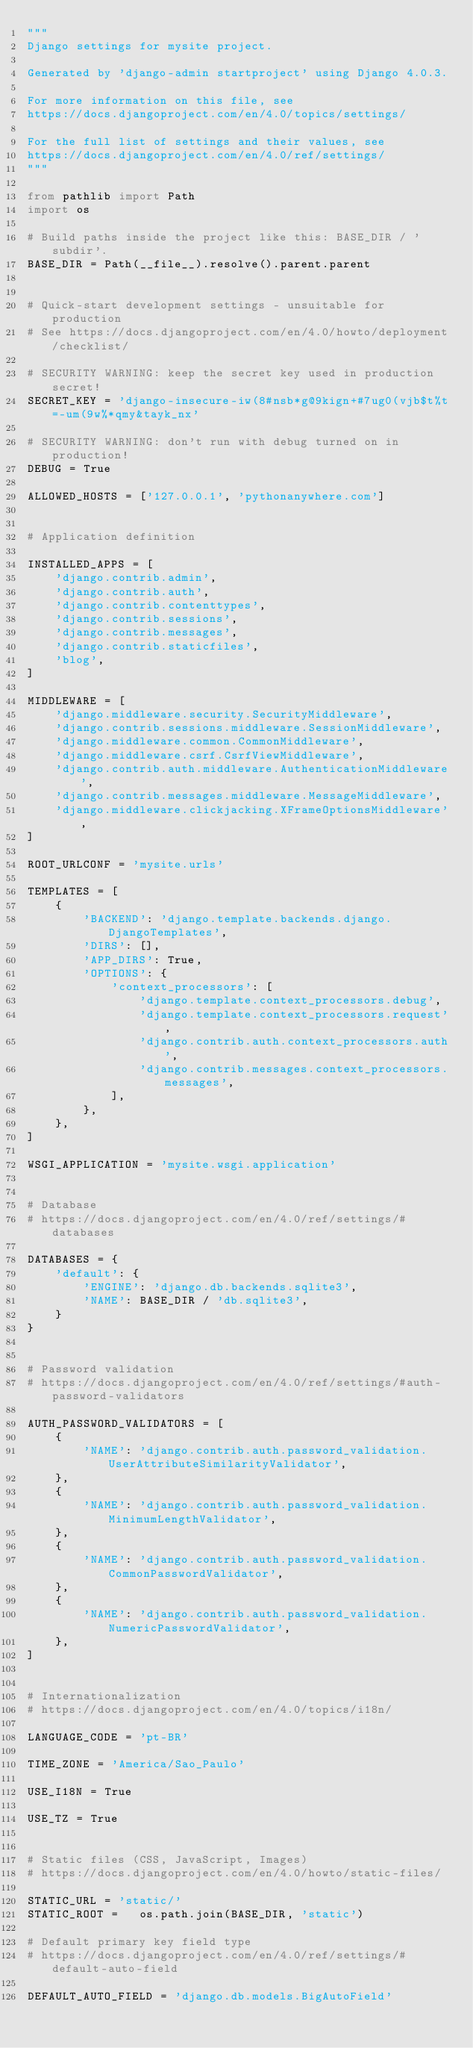<code> <loc_0><loc_0><loc_500><loc_500><_Python_>"""
Django settings for mysite project.

Generated by 'django-admin startproject' using Django 4.0.3.

For more information on this file, see
https://docs.djangoproject.com/en/4.0/topics/settings/

For the full list of settings and their values, see
https://docs.djangoproject.com/en/4.0/ref/settings/
"""

from pathlib import Path
import os

# Build paths inside the project like this: BASE_DIR / 'subdir'.
BASE_DIR = Path(__file__).resolve().parent.parent


# Quick-start development settings - unsuitable for production
# See https://docs.djangoproject.com/en/4.0/howto/deployment/checklist/

# SECURITY WARNING: keep the secret key used in production secret!
SECRET_KEY = 'django-insecure-iw(8#nsb*g@9kign+#7ug0(vjb$t%t=-um(9w%*qmy&tayk_nx'

# SECURITY WARNING: don't run with debug turned on in production!
DEBUG = True

ALLOWED_HOSTS = ['127.0.0.1', 'pythonanywhere.com']


# Application definition

INSTALLED_APPS = [
    'django.contrib.admin',
    'django.contrib.auth',
    'django.contrib.contenttypes',
    'django.contrib.sessions',
    'django.contrib.messages',
    'django.contrib.staticfiles',
	'blog',
]

MIDDLEWARE = [
    'django.middleware.security.SecurityMiddleware',
    'django.contrib.sessions.middleware.SessionMiddleware',
    'django.middleware.common.CommonMiddleware',
    'django.middleware.csrf.CsrfViewMiddleware',
    'django.contrib.auth.middleware.AuthenticationMiddleware',
    'django.contrib.messages.middleware.MessageMiddleware',
    'django.middleware.clickjacking.XFrameOptionsMiddleware',
]

ROOT_URLCONF = 'mysite.urls'

TEMPLATES = [
    {
        'BACKEND': 'django.template.backends.django.DjangoTemplates',
        'DIRS': [],
        'APP_DIRS': True,
        'OPTIONS': {
            'context_processors': [
                'django.template.context_processors.debug',
                'django.template.context_processors.request',
                'django.contrib.auth.context_processors.auth',
                'django.contrib.messages.context_processors.messages',
            ],
        },
    },
]

WSGI_APPLICATION = 'mysite.wsgi.application'


# Database
# https://docs.djangoproject.com/en/4.0/ref/settings/#databases

DATABASES = {
    'default': {
        'ENGINE': 'django.db.backends.sqlite3',
        'NAME': BASE_DIR / 'db.sqlite3',
    }
}


# Password validation
# https://docs.djangoproject.com/en/4.0/ref/settings/#auth-password-validators

AUTH_PASSWORD_VALIDATORS = [
    {
        'NAME': 'django.contrib.auth.password_validation.UserAttributeSimilarityValidator',
    },
    {
        'NAME': 'django.contrib.auth.password_validation.MinimumLengthValidator',
    },
    {
        'NAME': 'django.contrib.auth.password_validation.CommonPasswordValidator',
    },
    {
        'NAME': 'django.contrib.auth.password_validation.NumericPasswordValidator',
    },
]


# Internationalization
# https://docs.djangoproject.com/en/4.0/topics/i18n/

LANGUAGE_CODE = 'pt-BR'

TIME_ZONE = 'America/Sao_Paulo'

USE_I18N = True

USE_TZ = True


# Static files (CSS, JavaScript, Images)
# https://docs.djangoproject.com/en/4.0/howto/static-files/

STATIC_URL = 'static/'
STATIC_ROOT = 	os.path.join(BASE_DIR, 'static')

# Default primary key field type
# https://docs.djangoproject.com/en/4.0/ref/settings/#default-auto-field

DEFAULT_AUTO_FIELD = 'django.db.models.BigAutoField'
</code> 